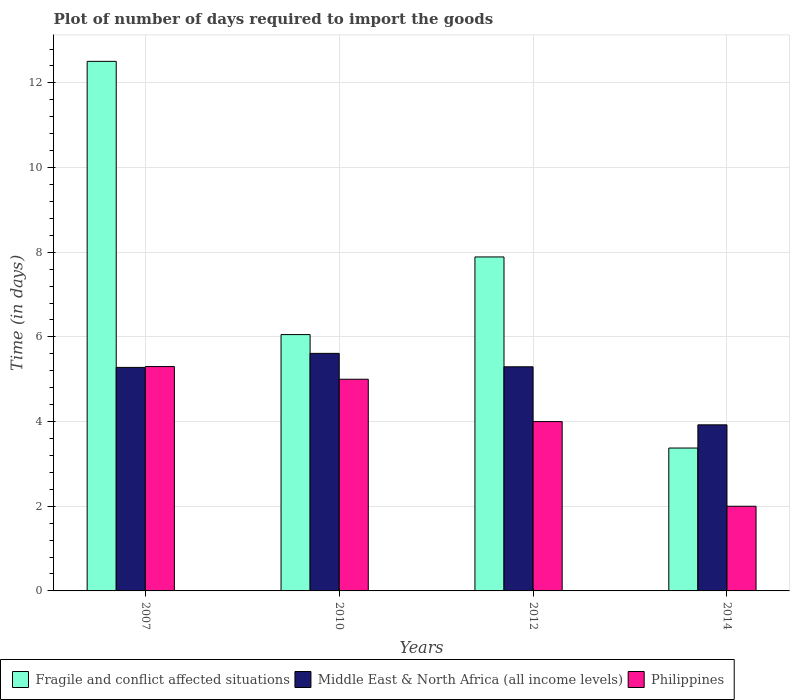Are the number of bars on each tick of the X-axis equal?
Provide a succinct answer. Yes. How many bars are there on the 3rd tick from the right?
Make the answer very short. 3. What is the label of the 1st group of bars from the left?
Offer a terse response. 2007. What is the time required to import goods in Fragile and conflict affected situations in 2012?
Ensure brevity in your answer.  7.89. Across all years, what is the maximum time required to import goods in Philippines?
Your response must be concise. 5.3. In which year was the time required to import goods in Fragile and conflict affected situations maximum?
Your response must be concise. 2007. In which year was the time required to import goods in Middle East & North Africa (all income levels) minimum?
Offer a very short reply. 2014. What is the total time required to import goods in Middle East & North Africa (all income levels) in the graph?
Provide a succinct answer. 20.11. What is the difference between the time required to import goods in Philippines in 2010 and that in 2014?
Ensure brevity in your answer.  3. What is the difference between the time required to import goods in Philippines in 2007 and the time required to import goods in Middle East & North Africa (all income levels) in 2012?
Give a very brief answer. 0.01. What is the average time required to import goods in Fragile and conflict affected situations per year?
Offer a very short reply. 7.46. In the year 2012, what is the difference between the time required to import goods in Fragile and conflict affected situations and time required to import goods in Middle East & North Africa (all income levels)?
Offer a terse response. 2.59. In how many years, is the time required to import goods in Philippines greater than 10 days?
Offer a very short reply. 0. Is the difference between the time required to import goods in Fragile and conflict affected situations in 2007 and 2010 greater than the difference between the time required to import goods in Middle East & North Africa (all income levels) in 2007 and 2010?
Your answer should be very brief. Yes. What is the difference between the highest and the second highest time required to import goods in Philippines?
Provide a succinct answer. 0.3. In how many years, is the time required to import goods in Fragile and conflict affected situations greater than the average time required to import goods in Fragile and conflict affected situations taken over all years?
Your answer should be compact. 2. What does the 3rd bar from the left in 2010 represents?
Give a very brief answer. Philippines. Is it the case that in every year, the sum of the time required to import goods in Middle East & North Africa (all income levels) and time required to import goods in Fragile and conflict affected situations is greater than the time required to import goods in Philippines?
Your response must be concise. Yes. What is the difference between two consecutive major ticks on the Y-axis?
Provide a short and direct response. 2. Are the values on the major ticks of Y-axis written in scientific E-notation?
Give a very brief answer. No. Does the graph contain any zero values?
Offer a very short reply. No. Does the graph contain grids?
Ensure brevity in your answer.  Yes. Where does the legend appear in the graph?
Your answer should be very brief. Bottom left. How many legend labels are there?
Provide a succinct answer. 3. How are the legend labels stacked?
Your response must be concise. Horizontal. What is the title of the graph?
Your answer should be very brief. Plot of number of days required to import the goods. What is the label or title of the Y-axis?
Your answer should be compact. Time (in days). What is the Time (in days) of Fragile and conflict affected situations in 2007?
Offer a very short reply. 12.51. What is the Time (in days) of Middle East & North Africa (all income levels) in 2007?
Give a very brief answer. 5.28. What is the Time (in days) in Fragile and conflict affected situations in 2010?
Provide a succinct answer. 6.05. What is the Time (in days) of Middle East & North Africa (all income levels) in 2010?
Offer a terse response. 5.61. What is the Time (in days) in Fragile and conflict affected situations in 2012?
Make the answer very short. 7.89. What is the Time (in days) in Middle East & North Africa (all income levels) in 2012?
Provide a short and direct response. 5.29. What is the Time (in days) in Philippines in 2012?
Give a very brief answer. 4. What is the Time (in days) in Fragile and conflict affected situations in 2014?
Keep it short and to the point. 3.38. What is the Time (in days) in Middle East & North Africa (all income levels) in 2014?
Keep it short and to the point. 3.92. What is the Time (in days) in Philippines in 2014?
Keep it short and to the point. 2. Across all years, what is the maximum Time (in days) of Fragile and conflict affected situations?
Provide a succinct answer. 12.51. Across all years, what is the maximum Time (in days) in Middle East & North Africa (all income levels)?
Give a very brief answer. 5.61. Across all years, what is the maximum Time (in days) of Philippines?
Provide a succinct answer. 5.3. Across all years, what is the minimum Time (in days) of Fragile and conflict affected situations?
Ensure brevity in your answer.  3.38. Across all years, what is the minimum Time (in days) in Middle East & North Africa (all income levels)?
Ensure brevity in your answer.  3.92. What is the total Time (in days) of Fragile and conflict affected situations in the graph?
Keep it short and to the point. 29.83. What is the total Time (in days) in Middle East & North Africa (all income levels) in the graph?
Ensure brevity in your answer.  20.11. What is the difference between the Time (in days) in Fragile and conflict affected situations in 2007 and that in 2010?
Give a very brief answer. 6.45. What is the difference between the Time (in days) in Middle East & North Africa (all income levels) in 2007 and that in 2010?
Make the answer very short. -0.33. What is the difference between the Time (in days) in Philippines in 2007 and that in 2010?
Offer a very short reply. 0.3. What is the difference between the Time (in days) of Fragile and conflict affected situations in 2007 and that in 2012?
Provide a succinct answer. 4.62. What is the difference between the Time (in days) of Middle East & North Africa (all income levels) in 2007 and that in 2012?
Provide a short and direct response. -0.01. What is the difference between the Time (in days) of Philippines in 2007 and that in 2012?
Offer a terse response. 1.3. What is the difference between the Time (in days) in Fragile and conflict affected situations in 2007 and that in 2014?
Your answer should be very brief. 9.13. What is the difference between the Time (in days) in Middle East & North Africa (all income levels) in 2007 and that in 2014?
Give a very brief answer. 1.36. What is the difference between the Time (in days) in Philippines in 2007 and that in 2014?
Provide a short and direct response. 3.3. What is the difference between the Time (in days) of Fragile and conflict affected situations in 2010 and that in 2012?
Provide a short and direct response. -1.83. What is the difference between the Time (in days) of Middle East & North Africa (all income levels) in 2010 and that in 2012?
Keep it short and to the point. 0.32. What is the difference between the Time (in days) in Philippines in 2010 and that in 2012?
Offer a terse response. 1. What is the difference between the Time (in days) in Fragile and conflict affected situations in 2010 and that in 2014?
Give a very brief answer. 2.68. What is the difference between the Time (in days) in Middle East & North Africa (all income levels) in 2010 and that in 2014?
Your answer should be very brief. 1.69. What is the difference between the Time (in days) of Philippines in 2010 and that in 2014?
Offer a very short reply. 3. What is the difference between the Time (in days) in Fragile and conflict affected situations in 2012 and that in 2014?
Make the answer very short. 4.51. What is the difference between the Time (in days) in Middle East & North Africa (all income levels) in 2012 and that in 2014?
Offer a very short reply. 1.37. What is the difference between the Time (in days) of Fragile and conflict affected situations in 2007 and the Time (in days) of Middle East & North Africa (all income levels) in 2010?
Offer a terse response. 6.9. What is the difference between the Time (in days) of Fragile and conflict affected situations in 2007 and the Time (in days) of Philippines in 2010?
Your response must be concise. 7.51. What is the difference between the Time (in days) in Middle East & North Africa (all income levels) in 2007 and the Time (in days) in Philippines in 2010?
Make the answer very short. 0.28. What is the difference between the Time (in days) in Fragile and conflict affected situations in 2007 and the Time (in days) in Middle East & North Africa (all income levels) in 2012?
Your response must be concise. 7.21. What is the difference between the Time (in days) in Fragile and conflict affected situations in 2007 and the Time (in days) in Philippines in 2012?
Your answer should be very brief. 8.51. What is the difference between the Time (in days) in Middle East & North Africa (all income levels) in 2007 and the Time (in days) in Philippines in 2012?
Your answer should be compact. 1.28. What is the difference between the Time (in days) in Fragile and conflict affected situations in 2007 and the Time (in days) in Middle East & North Africa (all income levels) in 2014?
Give a very brief answer. 8.59. What is the difference between the Time (in days) in Fragile and conflict affected situations in 2007 and the Time (in days) in Philippines in 2014?
Offer a very short reply. 10.51. What is the difference between the Time (in days) in Middle East & North Africa (all income levels) in 2007 and the Time (in days) in Philippines in 2014?
Give a very brief answer. 3.28. What is the difference between the Time (in days) of Fragile and conflict affected situations in 2010 and the Time (in days) of Middle East & North Africa (all income levels) in 2012?
Your answer should be very brief. 0.76. What is the difference between the Time (in days) of Fragile and conflict affected situations in 2010 and the Time (in days) of Philippines in 2012?
Offer a very short reply. 2.06. What is the difference between the Time (in days) in Middle East & North Africa (all income levels) in 2010 and the Time (in days) in Philippines in 2012?
Keep it short and to the point. 1.61. What is the difference between the Time (in days) of Fragile and conflict affected situations in 2010 and the Time (in days) of Middle East & North Africa (all income levels) in 2014?
Make the answer very short. 2.13. What is the difference between the Time (in days) in Fragile and conflict affected situations in 2010 and the Time (in days) in Philippines in 2014?
Your answer should be very brief. 4.05. What is the difference between the Time (in days) of Middle East & North Africa (all income levels) in 2010 and the Time (in days) of Philippines in 2014?
Your response must be concise. 3.61. What is the difference between the Time (in days) of Fragile and conflict affected situations in 2012 and the Time (in days) of Middle East & North Africa (all income levels) in 2014?
Your answer should be compact. 3.97. What is the difference between the Time (in days) of Fragile and conflict affected situations in 2012 and the Time (in days) of Philippines in 2014?
Your answer should be very brief. 5.89. What is the difference between the Time (in days) of Middle East & North Africa (all income levels) in 2012 and the Time (in days) of Philippines in 2014?
Ensure brevity in your answer.  3.29. What is the average Time (in days) in Fragile and conflict affected situations per year?
Offer a terse response. 7.46. What is the average Time (in days) in Middle East & North Africa (all income levels) per year?
Your response must be concise. 5.03. What is the average Time (in days) in Philippines per year?
Give a very brief answer. 4.08. In the year 2007, what is the difference between the Time (in days) in Fragile and conflict affected situations and Time (in days) in Middle East & North Africa (all income levels)?
Keep it short and to the point. 7.23. In the year 2007, what is the difference between the Time (in days) of Fragile and conflict affected situations and Time (in days) of Philippines?
Your response must be concise. 7.21. In the year 2007, what is the difference between the Time (in days) in Middle East & North Africa (all income levels) and Time (in days) in Philippines?
Your answer should be very brief. -0.02. In the year 2010, what is the difference between the Time (in days) in Fragile and conflict affected situations and Time (in days) in Middle East & North Africa (all income levels)?
Your answer should be compact. 0.44. In the year 2010, what is the difference between the Time (in days) in Fragile and conflict affected situations and Time (in days) in Philippines?
Keep it short and to the point. 1.05. In the year 2010, what is the difference between the Time (in days) of Middle East & North Africa (all income levels) and Time (in days) of Philippines?
Provide a short and direct response. 0.61. In the year 2012, what is the difference between the Time (in days) of Fragile and conflict affected situations and Time (in days) of Middle East & North Africa (all income levels)?
Offer a terse response. 2.59. In the year 2012, what is the difference between the Time (in days) of Fragile and conflict affected situations and Time (in days) of Philippines?
Your answer should be compact. 3.89. In the year 2012, what is the difference between the Time (in days) of Middle East & North Africa (all income levels) and Time (in days) of Philippines?
Provide a succinct answer. 1.29. In the year 2014, what is the difference between the Time (in days) of Fragile and conflict affected situations and Time (in days) of Middle East & North Africa (all income levels)?
Ensure brevity in your answer.  -0.55. In the year 2014, what is the difference between the Time (in days) in Fragile and conflict affected situations and Time (in days) in Philippines?
Your response must be concise. 1.38. In the year 2014, what is the difference between the Time (in days) of Middle East & North Africa (all income levels) and Time (in days) of Philippines?
Provide a short and direct response. 1.92. What is the ratio of the Time (in days) of Fragile and conflict affected situations in 2007 to that in 2010?
Offer a terse response. 2.07. What is the ratio of the Time (in days) of Middle East & North Africa (all income levels) in 2007 to that in 2010?
Ensure brevity in your answer.  0.94. What is the ratio of the Time (in days) of Philippines in 2007 to that in 2010?
Your response must be concise. 1.06. What is the ratio of the Time (in days) of Fragile and conflict affected situations in 2007 to that in 2012?
Your answer should be very brief. 1.59. What is the ratio of the Time (in days) in Philippines in 2007 to that in 2012?
Your answer should be compact. 1.32. What is the ratio of the Time (in days) in Fragile and conflict affected situations in 2007 to that in 2014?
Your answer should be very brief. 3.71. What is the ratio of the Time (in days) in Middle East & North Africa (all income levels) in 2007 to that in 2014?
Ensure brevity in your answer.  1.35. What is the ratio of the Time (in days) in Philippines in 2007 to that in 2014?
Ensure brevity in your answer.  2.65. What is the ratio of the Time (in days) of Fragile and conflict affected situations in 2010 to that in 2012?
Your answer should be compact. 0.77. What is the ratio of the Time (in days) of Middle East & North Africa (all income levels) in 2010 to that in 2012?
Provide a short and direct response. 1.06. What is the ratio of the Time (in days) in Fragile and conflict affected situations in 2010 to that in 2014?
Ensure brevity in your answer.  1.79. What is the ratio of the Time (in days) in Middle East & North Africa (all income levels) in 2010 to that in 2014?
Make the answer very short. 1.43. What is the ratio of the Time (in days) in Fragile and conflict affected situations in 2012 to that in 2014?
Ensure brevity in your answer.  2.34. What is the ratio of the Time (in days) of Middle East & North Africa (all income levels) in 2012 to that in 2014?
Offer a terse response. 1.35. What is the difference between the highest and the second highest Time (in days) of Fragile and conflict affected situations?
Offer a very short reply. 4.62. What is the difference between the highest and the second highest Time (in days) of Middle East & North Africa (all income levels)?
Keep it short and to the point. 0.32. What is the difference between the highest and the lowest Time (in days) of Fragile and conflict affected situations?
Provide a succinct answer. 9.13. What is the difference between the highest and the lowest Time (in days) in Middle East & North Africa (all income levels)?
Keep it short and to the point. 1.69. 